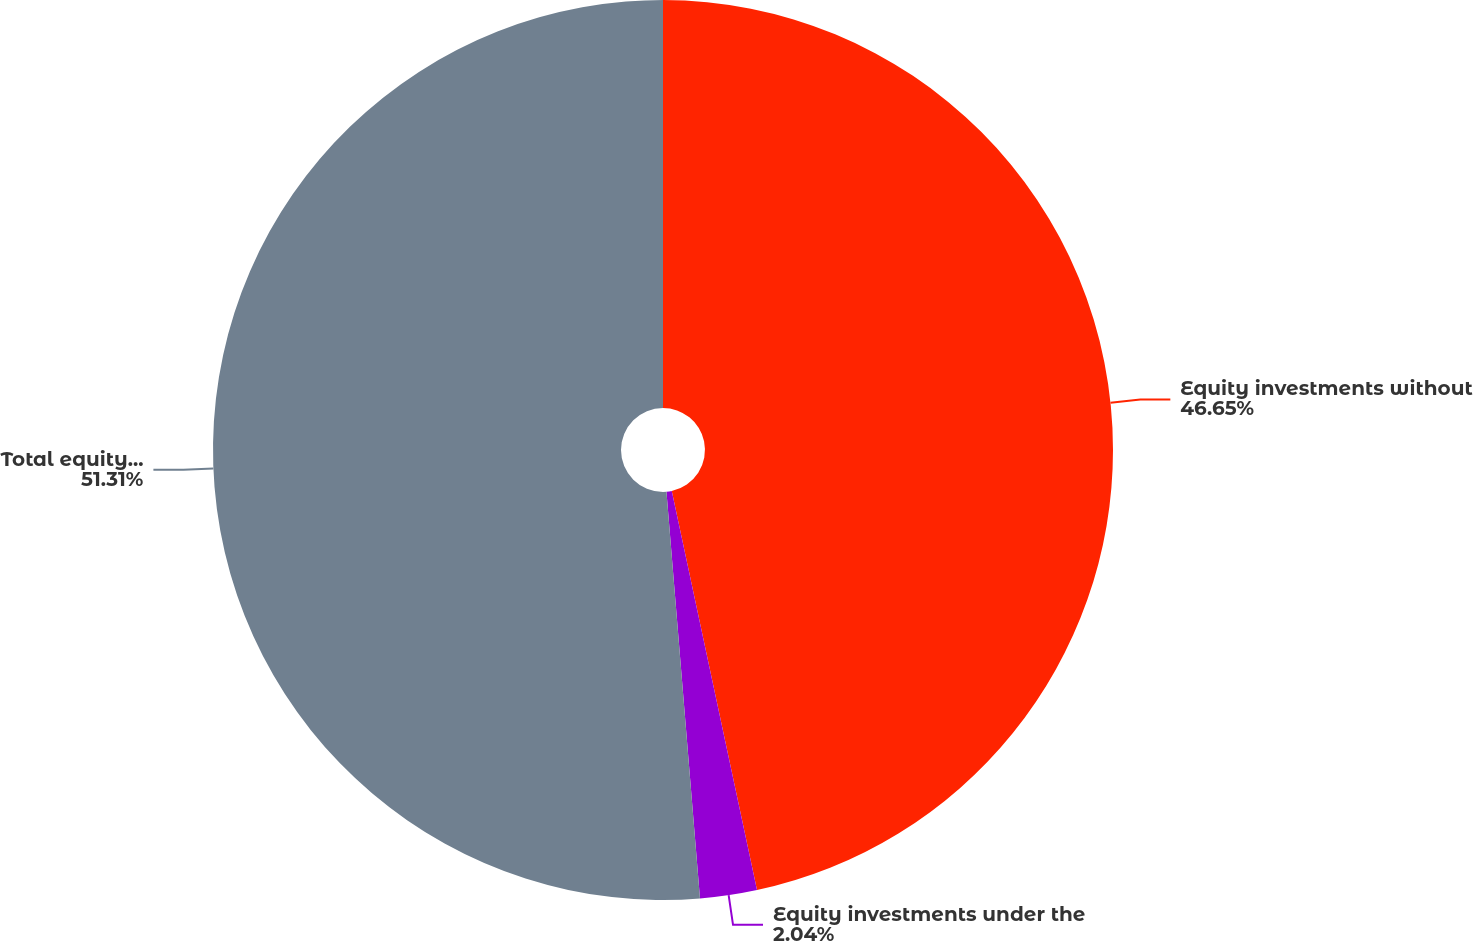Convert chart to OTSL. <chart><loc_0><loc_0><loc_500><loc_500><pie_chart><fcel>Equity investments without<fcel>Equity investments under the<fcel>Total equity investments<nl><fcel>46.65%<fcel>2.04%<fcel>51.31%<nl></chart> 